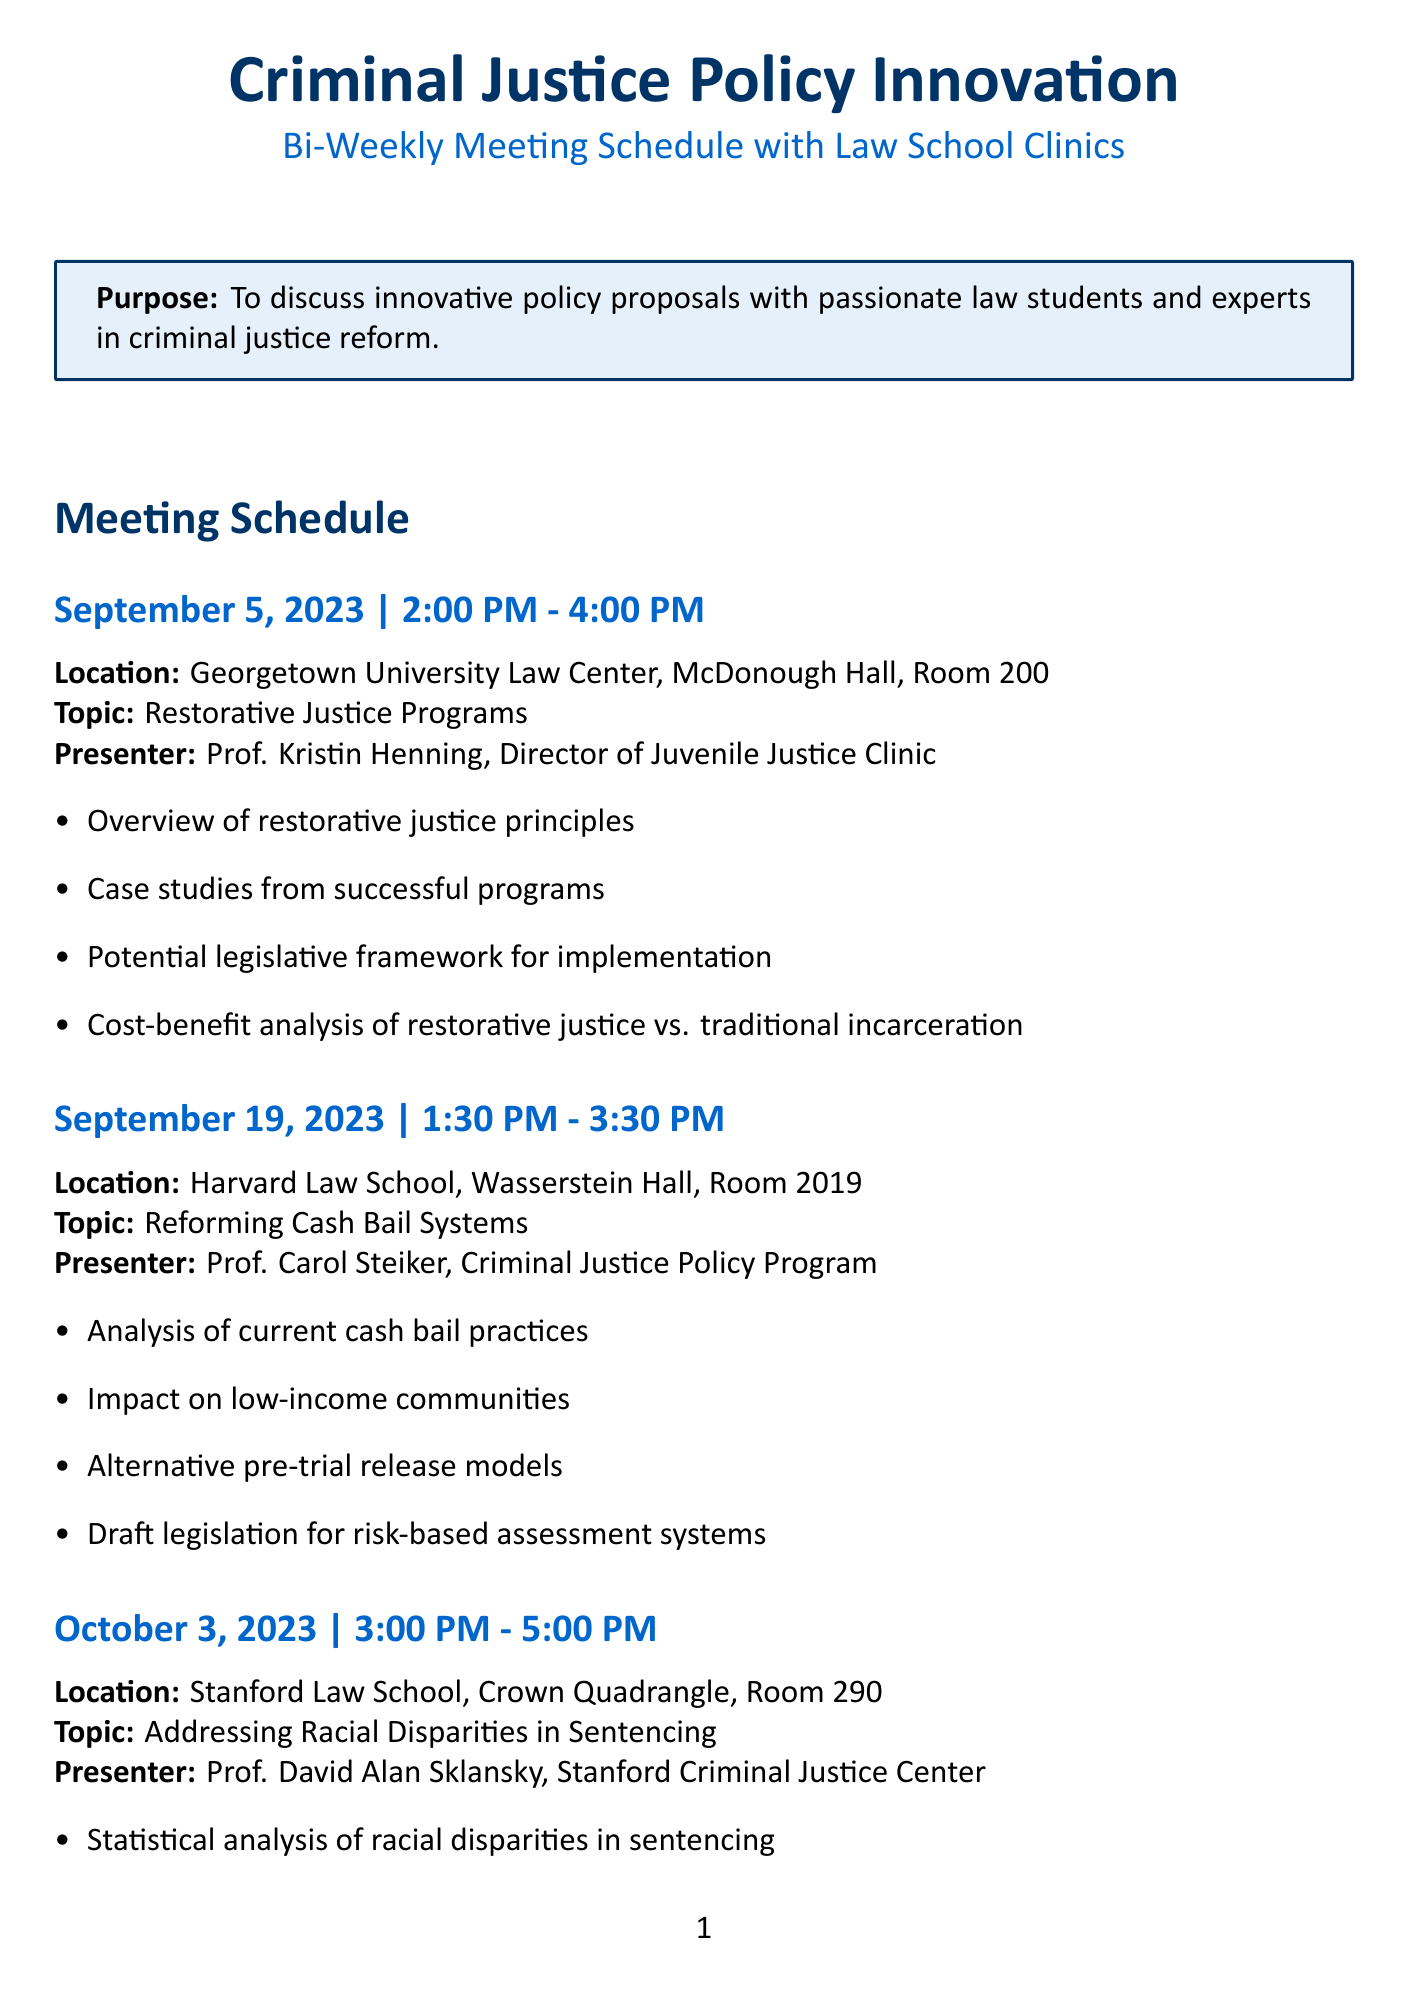What is the date of the meeting on Restorative Justice Programs? The document clearly states that the meeting on Restorative Justice Programs is scheduled for September 5, 2023.
Answer: September 5, 2023 Who is the presenter for the meeting on Reforming Cash Bail Systems? The document lists Prof. Carol Steiker as the presenter for the meeting on Reforming Cash Bail Systems.
Answer: Prof. Carol Steiker What is the location for the meeting on Addressing Racial Disparities in Sentencing? According to the document, the meeting on Addressing Racial Disparities in Sentencing takes place at Stanford Law School, Crown Quadrangle, Room 290.
Answer: Stanford Law School, Crown Quadrangle, Room 290 How long is the meeting on Expanding Mental Health Courts scheduled to last? The document indicates that the meeting on Expanding Mental Health Courts is scheduled to last from 2:30 PM to 4:30 PM, which is a duration of 2 hours.
Answer: 2 hours What is one of the key points discussed in the meeting focusing on Reforming Juvenile Justice? The document mentions that one of the key points is the proposal for expanded diversion programs for youth.
Answer: Proposal for expanded diversion programs Which law school will host the meeting on Implementing Evidence-Based Policing Practices? The document states that the meeting on Implementing Evidence-Based Policing Practices will be hosted by Yale Law School.
Answer: Yale Law School What is the scheduled time for the meeting on Reforming Cash Bail Systems? As per the document, the meeting is scheduled from 1:30 PM to 3:30 PM.
Answer: 1:30 PM - 3:30 PM List a topic discussed at the meeting on October 31, 2023. The document indicates that the topic discussed during this meeting will be Reforming Juvenile Justice: Alternatives to Incarceration.
Answer: Reforming Juvenile Justice: Alternatives to Incarceration 